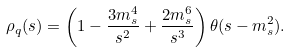<formula> <loc_0><loc_0><loc_500><loc_500>\rho _ { q } ( s ) = \left ( 1 - \frac { 3 m _ { s } ^ { 4 } } { s ^ { 2 } } + \frac { 2 m _ { s } ^ { 6 } } { s ^ { 3 } } \right ) \theta ( s - m _ { s } ^ { 2 } ) .</formula> 